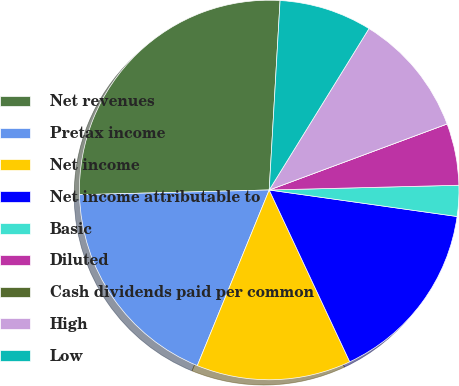<chart> <loc_0><loc_0><loc_500><loc_500><pie_chart><fcel>Net revenues<fcel>Pretax income<fcel>Net income<fcel>Net income attributable to<fcel>Basic<fcel>Diluted<fcel>Cash dividends paid per common<fcel>High<fcel>Low<nl><fcel>26.31%<fcel>18.42%<fcel>13.16%<fcel>15.79%<fcel>2.63%<fcel>5.26%<fcel>0.0%<fcel>10.53%<fcel>7.9%<nl></chart> 